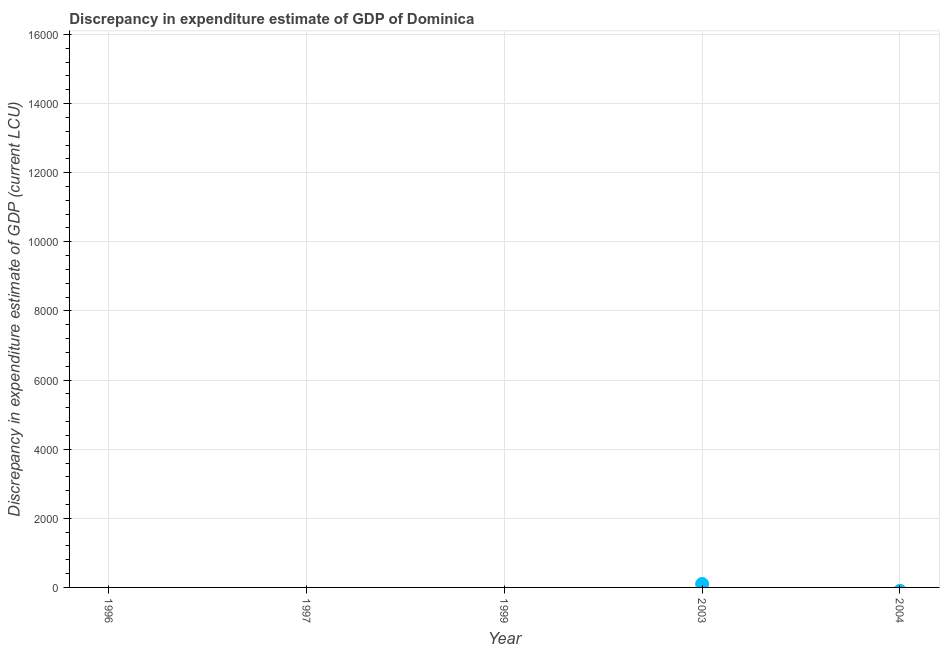Across all years, what is the maximum discrepancy in expenditure estimate of gdp?
Keep it short and to the point. 100. What is the median discrepancy in expenditure estimate of gdp?
Offer a very short reply. 0. Does the discrepancy in expenditure estimate of gdp monotonically increase over the years?
Offer a terse response. No. How many dotlines are there?
Offer a very short reply. 1. How many years are there in the graph?
Provide a succinct answer. 5. What is the difference between two consecutive major ticks on the Y-axis?
Keep it short and to the point. 2000. Are the values on the major ticks of Y-axis written in scientific E-notation?
Your answer should be compact. No. What is the title of the graph?
Provide a succinct answer. Discrepancy in expenditure estimate of GDP of Dominica. What is the label or title of the X-axis?
Give a very brief answer. Year. What is the label or title of the Y-axis?
Make the answer very short. Discrepancy in expenditure estimate of GDP (current LCU). What is the Discrepancy in expenditure estimate of GDP (current LCU) in 1996?
Provide a succinct answer. 0. What is the Discrepancy in expenditure estimate of GDP (current LCU) in 2004?
Your answer should be compact. 0. 